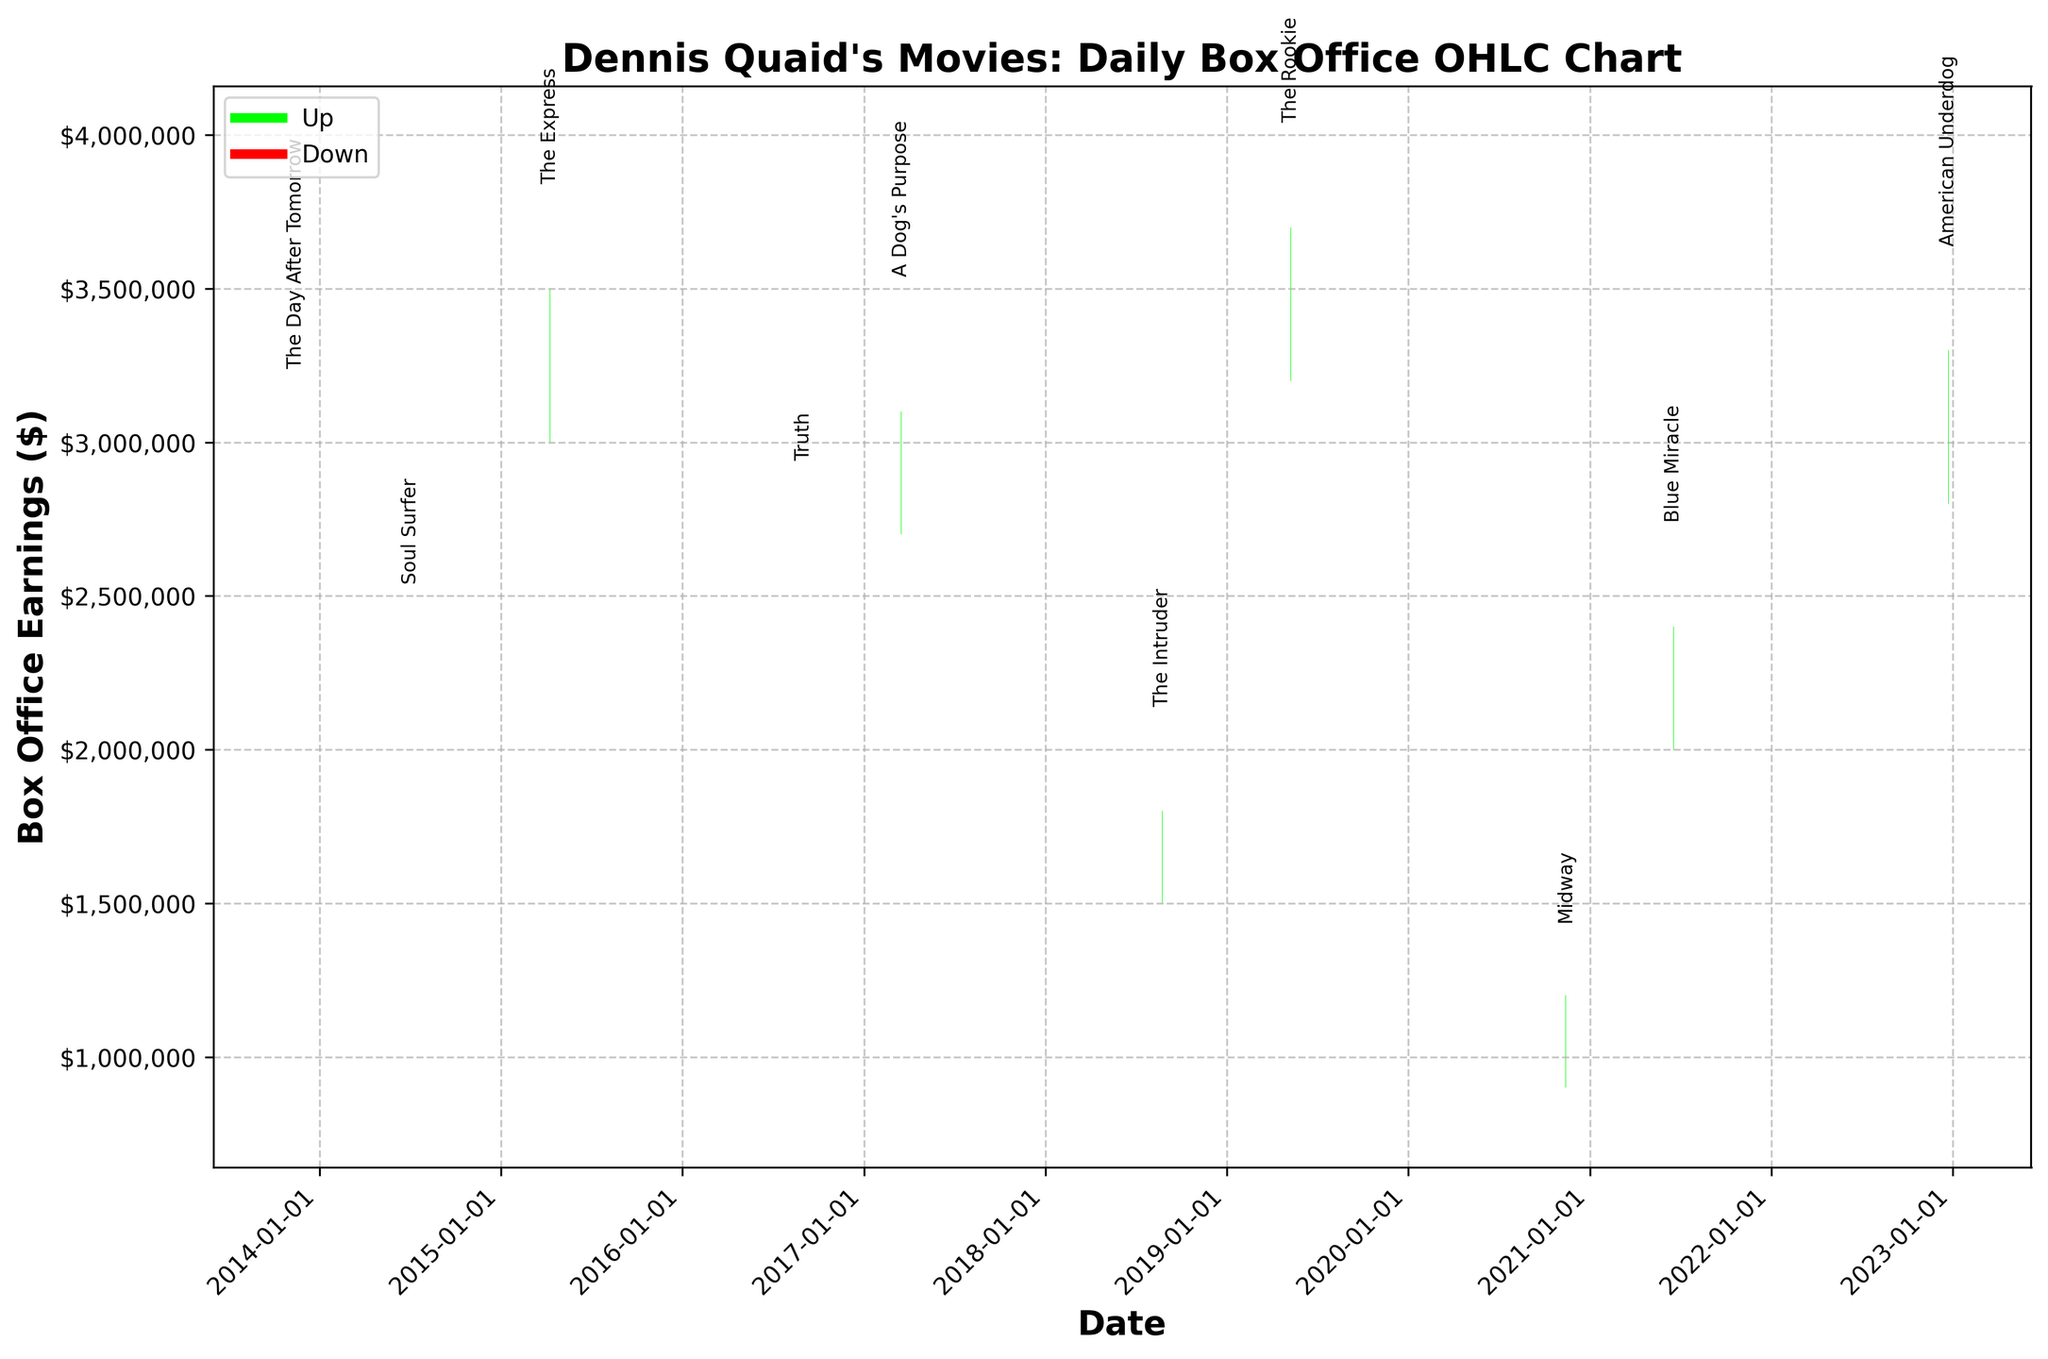What is the title of the chart? The title is located at the top of the chart and is written in bold.
Answer: Dennis Quaid's Movies: Daily Box Office OHLC Chart What is the highest closing earning and for which movie? Look for the highest value on the y-axis within the closing prices, then identify the corresponding movie.
Answer: The Rookie with $3,700,000 Which movie had the lowest opening earnings? Identify the smallest opening value on the y-axis, then find the corresponding movie title annotated on the chart.
Answer: Midway How many movies closed in a higher price than they opened? Count the green bars, which indicate closing prices higher than the opening prices.
Answer: 7 movies Between "The Day After Tomorrow" and "Soul Surfer", which had a higher high price and by how much? Locate both movies on the x-axis, find their high price values, and calculate the difference between them.
Answer: The Day After Tomorrow by $700,000 What was the average closing earning for all movies? Sum all the closing earnings and divide by the number of movies. Calculate the sum of each closing price and divide by 10.
Answer: $2,585,000 Which movie had the largest range between the high and low prices? Compute the difference between high and low prices for all movies, and identify the movie with the largest difference.
Answer: The Rookie with $1,100,000 For the movie "Midway", what was the percentage change from open to close? Calculate the percentage change using the formula (Close - Open) / Open * 100.
Answer: 33.33% How many movies had their highest earnings during "blockbuster" months (June-August, December)? Identify the movies released in these months and count them considering those with higher values in their ranges.
Answer: 5 movies Which movie experienced a significant drop from its high to close price? Identify the movie with the largest difference between high and close prices.
Answer: Midway 